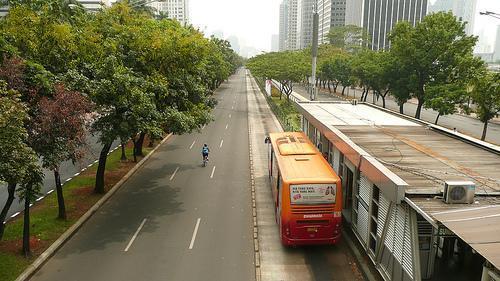How many people are there?
Give a very brief answer. 1. How many trees have brown leaves?
Give a very brief answer. 1. 